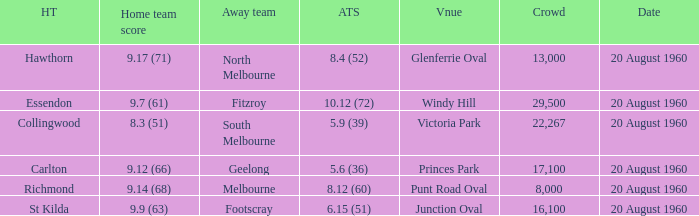What is the crowd size of the game when Fitzroy is the away team? 1.0. 